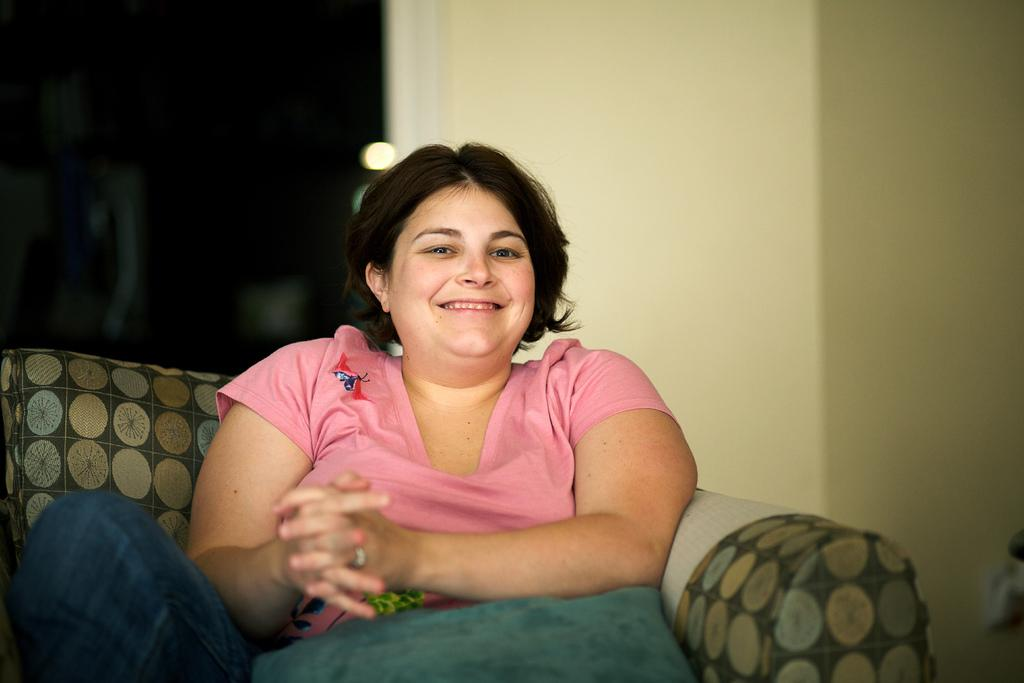Who is present in the image? There is a woman in the image. What is the woman wearing? The woman is wearing a pink t-shirt. What is the woman sitting on? The woman is sitting on a sofa. What can be seen behind the woman? There is a wall behind the woman. What type of bomb is the woman holding in the image? There is no bomb present in the image; the woman is simply sitting on a sofa wearing a pink t-shirt. 